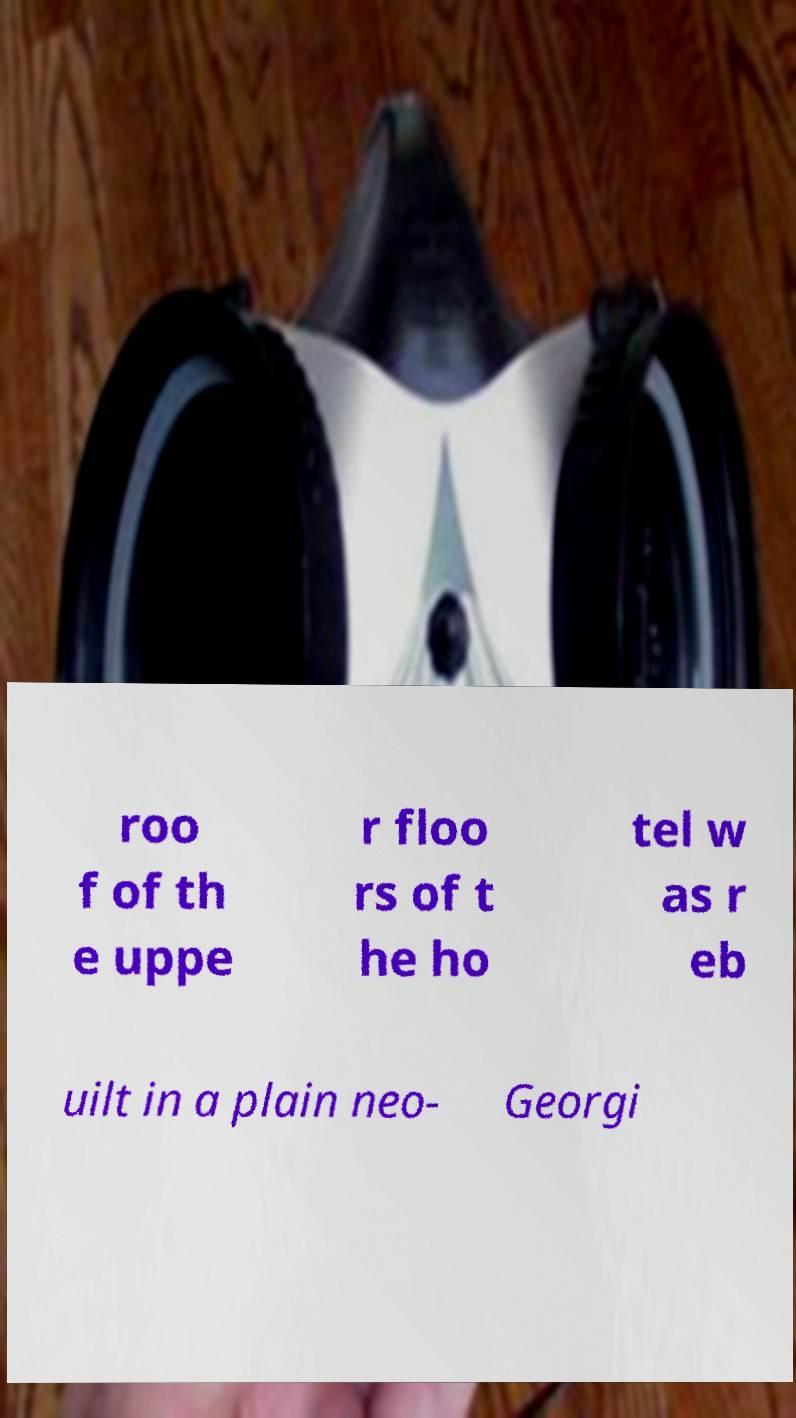For documentation purposes, I need the text within this image transcribed. Could you provide that? roo f of th e uppe r floo rs of t he ho tel w as r eb uilt in a plain neo- Georgi 